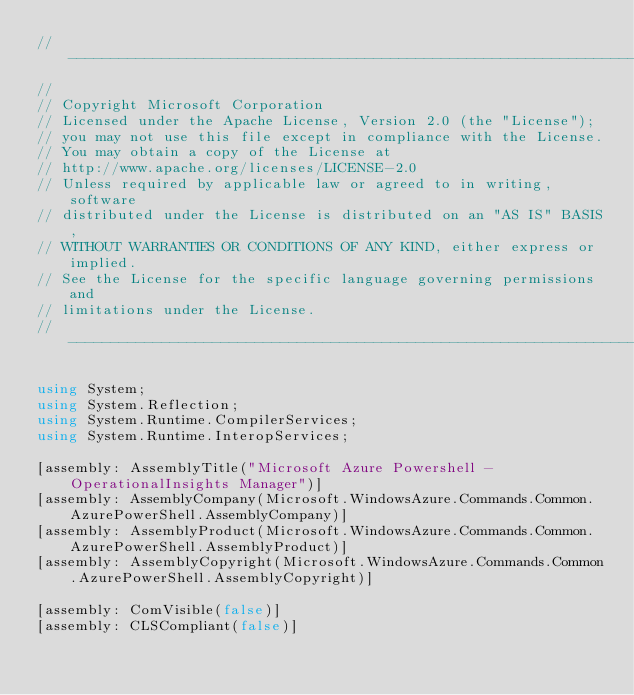Convert code to text. <code><loc_0><loc_0><loc_500><loc_500><_C#_>// ----------------------------------------------------------------------------------
//
// Copyright Microsoft Corporation
// Licensed under the Apache License, Version 2.0 (the "License");
// you may not use this file except in compliance with the License.
// You may obtain a copy of the License at
// http://www.apache.org/licenses/LICENSE-2.0
// Unless required by applicable law or agreed to in writing, software
// distributed under the License is distributed on an "AS IS" BASIS,
// WITHOUT WARRANTIES OR CONDITIONS OF ANY KIND, either express or implied.
// See the License for the specific language governing permissions and
// limitations under the License.
// ----------------------------------------------------------------------------------

using System;
using System.Reflection;
using System.Runtime.CompilerServices;
using System.Runtime.InteropServices;

[assembly: AssemblyTitle("Microsoft Azure Powershell - OperationalInsights Manager")]
[assembly: AssemblyCompany(Microsoft.WindowsAzure.Commands.Common.AzurePowerShell.AssemblyCompany)]
[assembly: AssemblyProduct(Microsoft.WindowsAzure.Commands.Common.AzurePowerShell.AssemblyProduct)]
[assembly: AssemblyCopyright(Microsoft.WindowsAzure.Commands.Common.AzurePowerShell.AssemblyCopyright)]

[assembly: ComVisible(false)]
[assembly: CLSCompliant(false)]</code> 